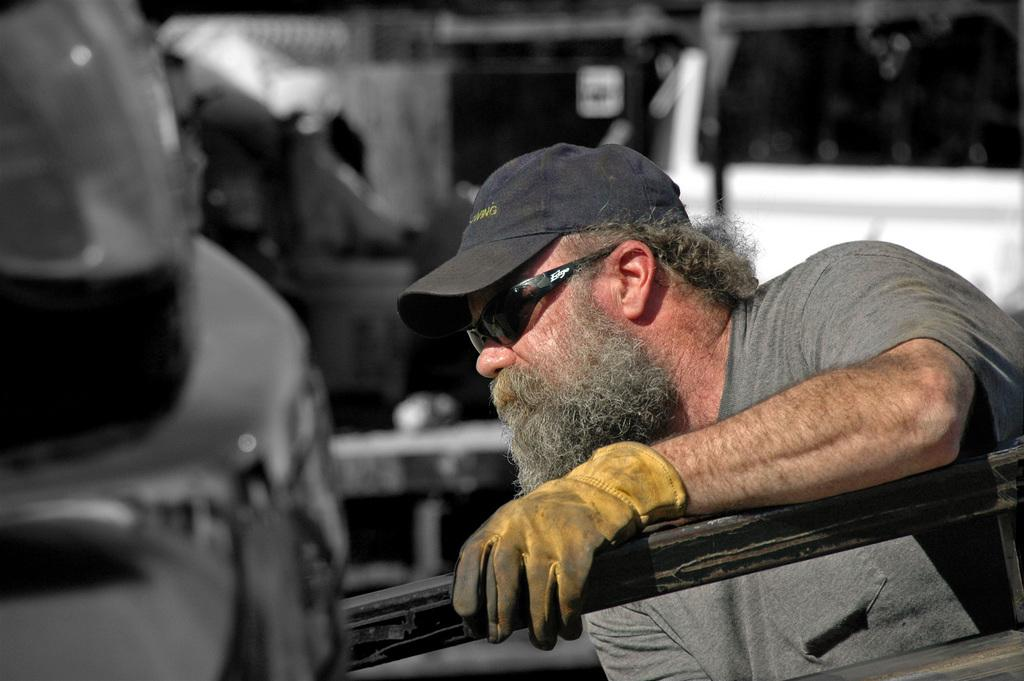What is the main subject of the picture? The main subject of the picture is a man. What is the man holding in the picture? The man is holding a metal rod. Can you describe the man's clothing in the picture? The man is wearing a t-shirt, goggles, and a cap. What type of guitar is the man playing in the image? There is no guitar present in the image; the man is holding a metal rod. What direction is the man facing in the image? The provided facts do not specify the direction the man is facing, so we cannot definitively answer this question. 